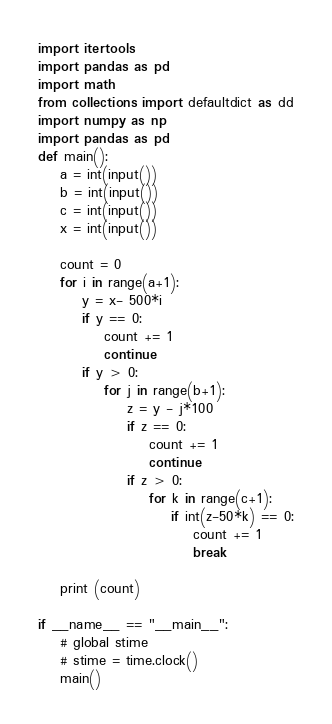<code> <loc_0><loc_0><loc_500><loc_500><_Python_>import itertools
import pandas as pd
import math 
from collections import defaultdict as dd
import numpy as np
import pandas as pd
def main():
	a = int(input())
	b = int(input())
	c = int(input())
	x = int(input())

	count = 0
	for i in range(a+1):
		y = x- 500*i
		if y == 0:
			count += 1
			continue
		if y > 0:
			for j in range(b+1):
				z = y - j*100
				if z == 0:
					count += 1
					continue
				if z > 0:
					for k in range(c+1):
						if int(z-50*k) == 0:
							count += 1
							break

	print (count)

if __name__ == "__main__":
    # global stime
    # stime = time.clock()
    main()

</code> 